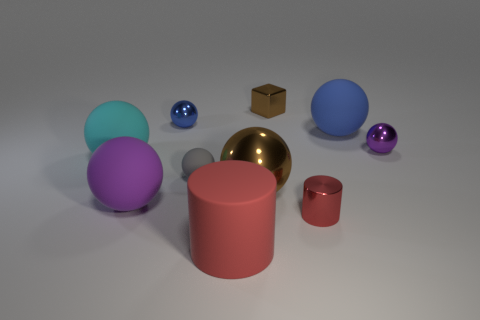How many red cylinders must be subtracted to get 1 red cylinders? 1 Subtract 4 spheres. How many spheres are left? 3 Subtract all blue balls. How many balls are left? 5 Subtract all big blue rubber spheres. How many spheres are left? 6 Subtract all gray spheres. Subtract all brown cylinders. How many spheres are left? 6 Subtract all cylinders. How many objects are left? 8 Add 7 small blue shiny things. How many small blue shiny things are left? 8 Add 1 rubber objects. How many rubber objects exist? 6 Subtract 0 yellow blocks. How many objects are left? 10 Subtract all tiny yellow objects. Subtract all large brown metal things. How many objects are left? 9 